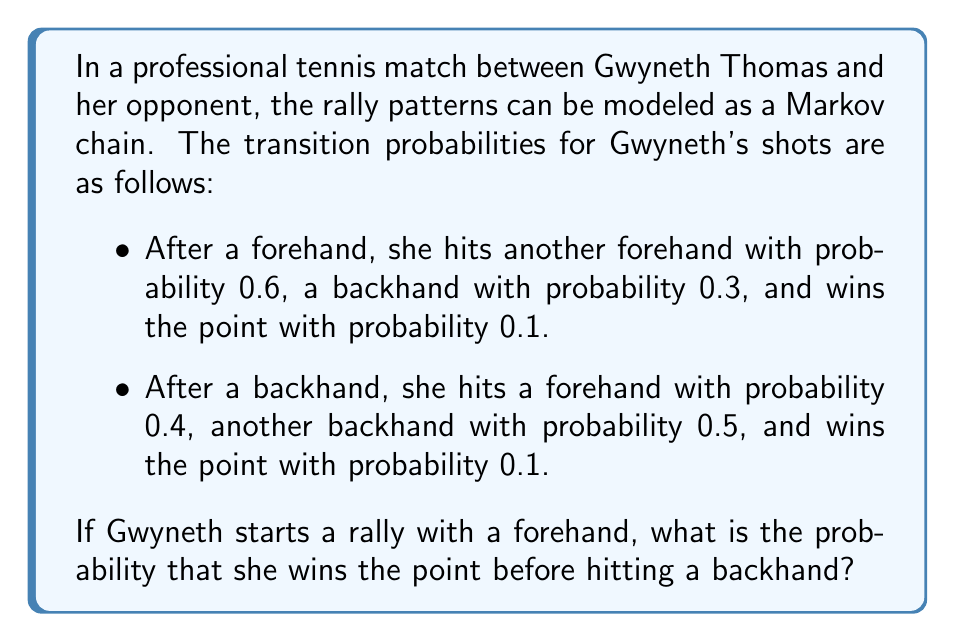Provide a solution to this math problem. Let's approach this step-by-step using Markov chain analysis:

1) We have three states: Forehand (F), Backhand (B), and Win (W). We want to find the probability of reaching W before B, starting from F.

2) Let $p$ be the probability of winning before hitting a backhand, starting from a forehand. We can set up an equation based on the possible outcomes after hitting a forehand:

   $p = 0.1 + 0.6p + 0.3 \cdot 0$

3) The equation can be explained as follows:
   - 0.1 is the probability of winning directly from a forehand
   - 0.6p is the probability of hitting another forehand and then winning from there
   - 0.3 · 0 is the probability of hitting a backhand (which ends our calculation)

4) Simplify the equation:
   $p = 0.1 + 0.6p$

5) Solve for $p$:
   $0.4p = 0.1$
   $p = 0.1 / 0.4 = 0.25$

Therefore, the probability that Gwyneth wins the point before hitting a backhand, given that she starts with a forehand, is 0.25 or 25%.
Answer: 0.25 